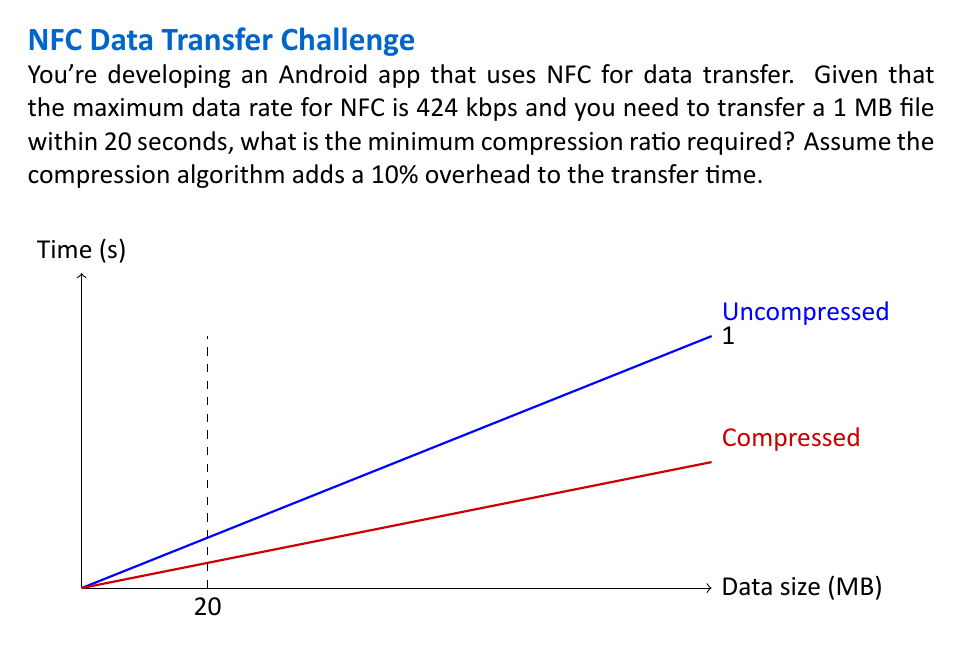What is the answer to this math problem? Let's approach this step-by-step:

1) First, let's convert the units:
   424 kbps = 424,000 bits/s = 53,000 bytes/s ≈ 0.0506 MB/s

2) In 20 seconds, we can transfer:
   $$ 20 \text{ s} \times 0.0506 \text{ MB/s} = 1.012 \text{ MB} $$

3) However, we need to account for the 10% overhead:
   $$ \text{Effective transfer capacity} = 1.012 \text{ MB} \div 1.1 \approx 0.92 \text{ MB} $$

4) The compression ratio (CR) is defined as:
   $$ CR = \frac{\text{Uncompressed size}}{\text{Compressed size}} $$

5) We need to compress 1 MB to 0.92 MB or less. So:
   $$ CR \geq \frac{1 \text{ MB}}{0.92 \text{ MB}} \approx 1.087 $$

6) To express this as a percentage reduction:
   $$ \text{Reduction} = (1 - \frac{1}{CR}) \times 100\% $$
   $$ \approx (1 - \frac{1}{1.087}) \times 100\% \approx 8\% $$

Therefore, we need to compress the data by at least 8% to transfer it within the given constraints.
Answer: 1.087 (or 8% reduction) 